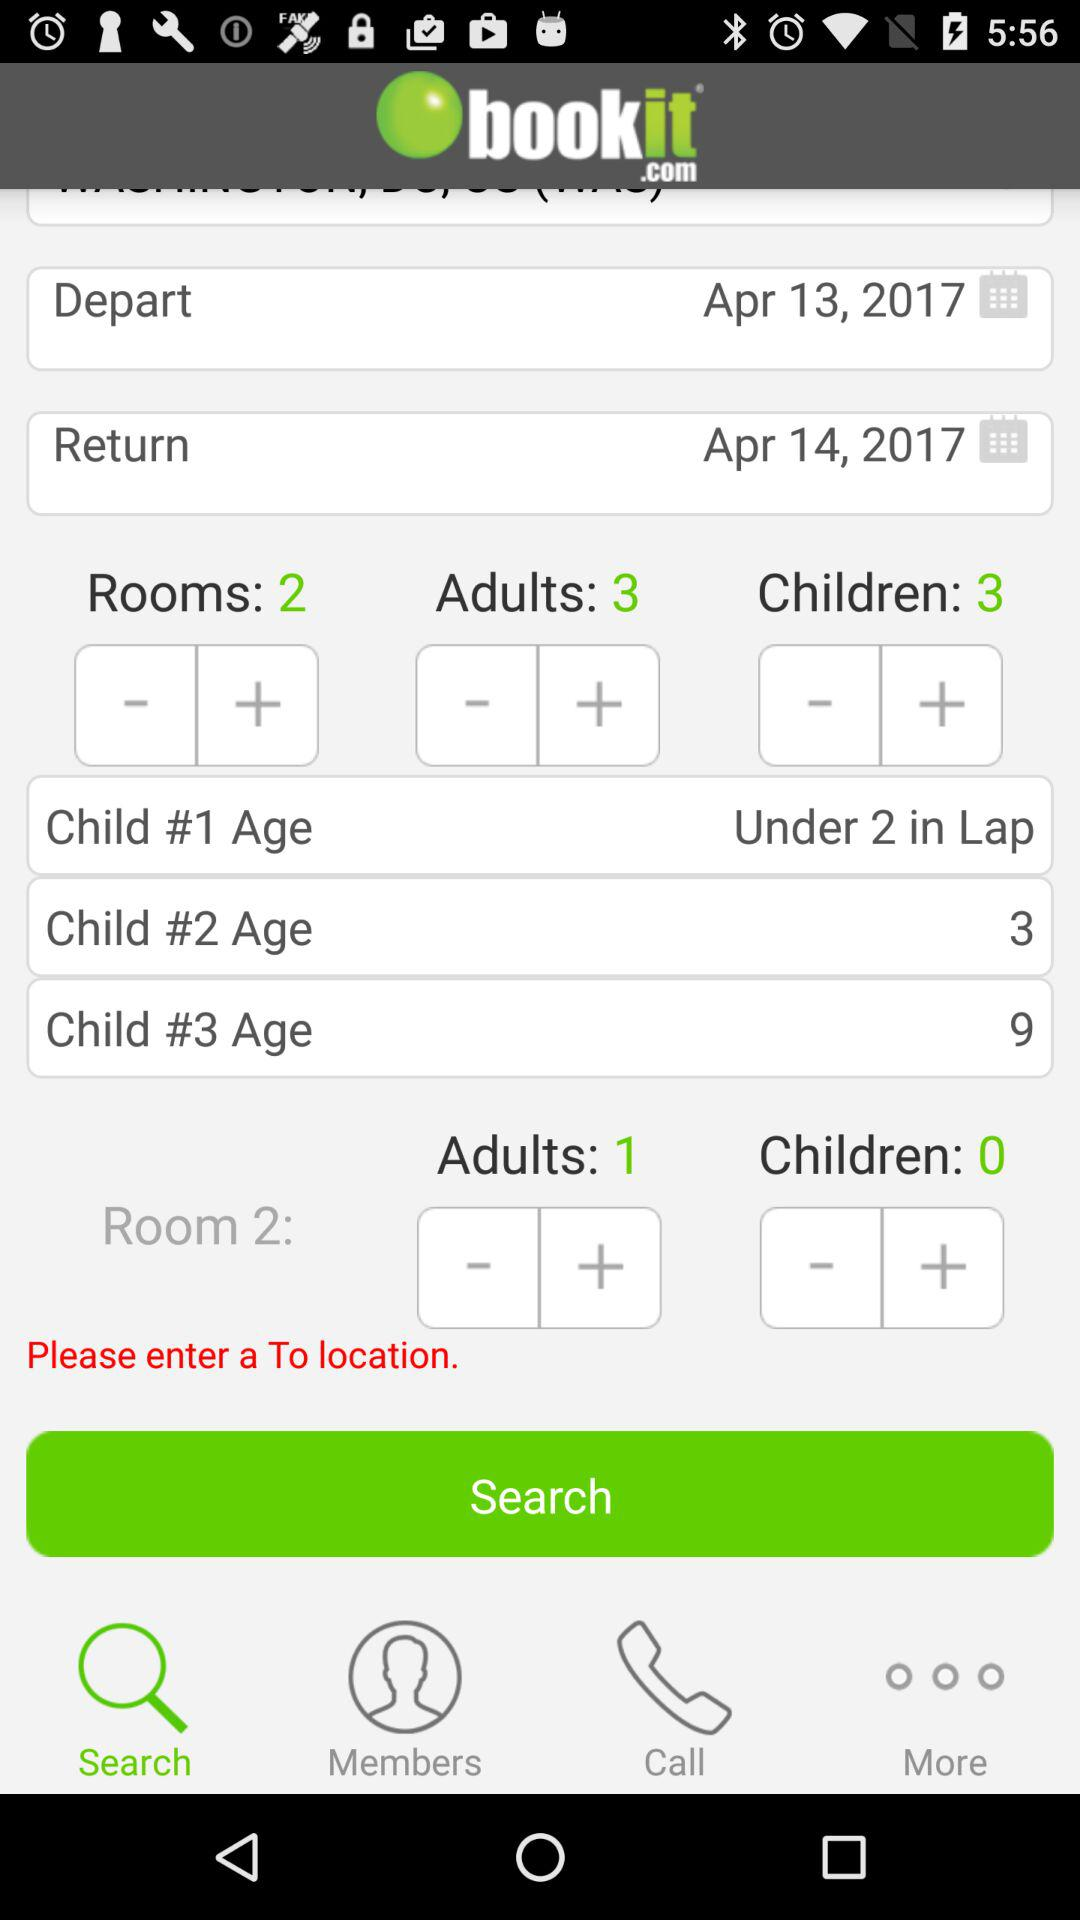What is the return date? The return date is April 14, 2017. 